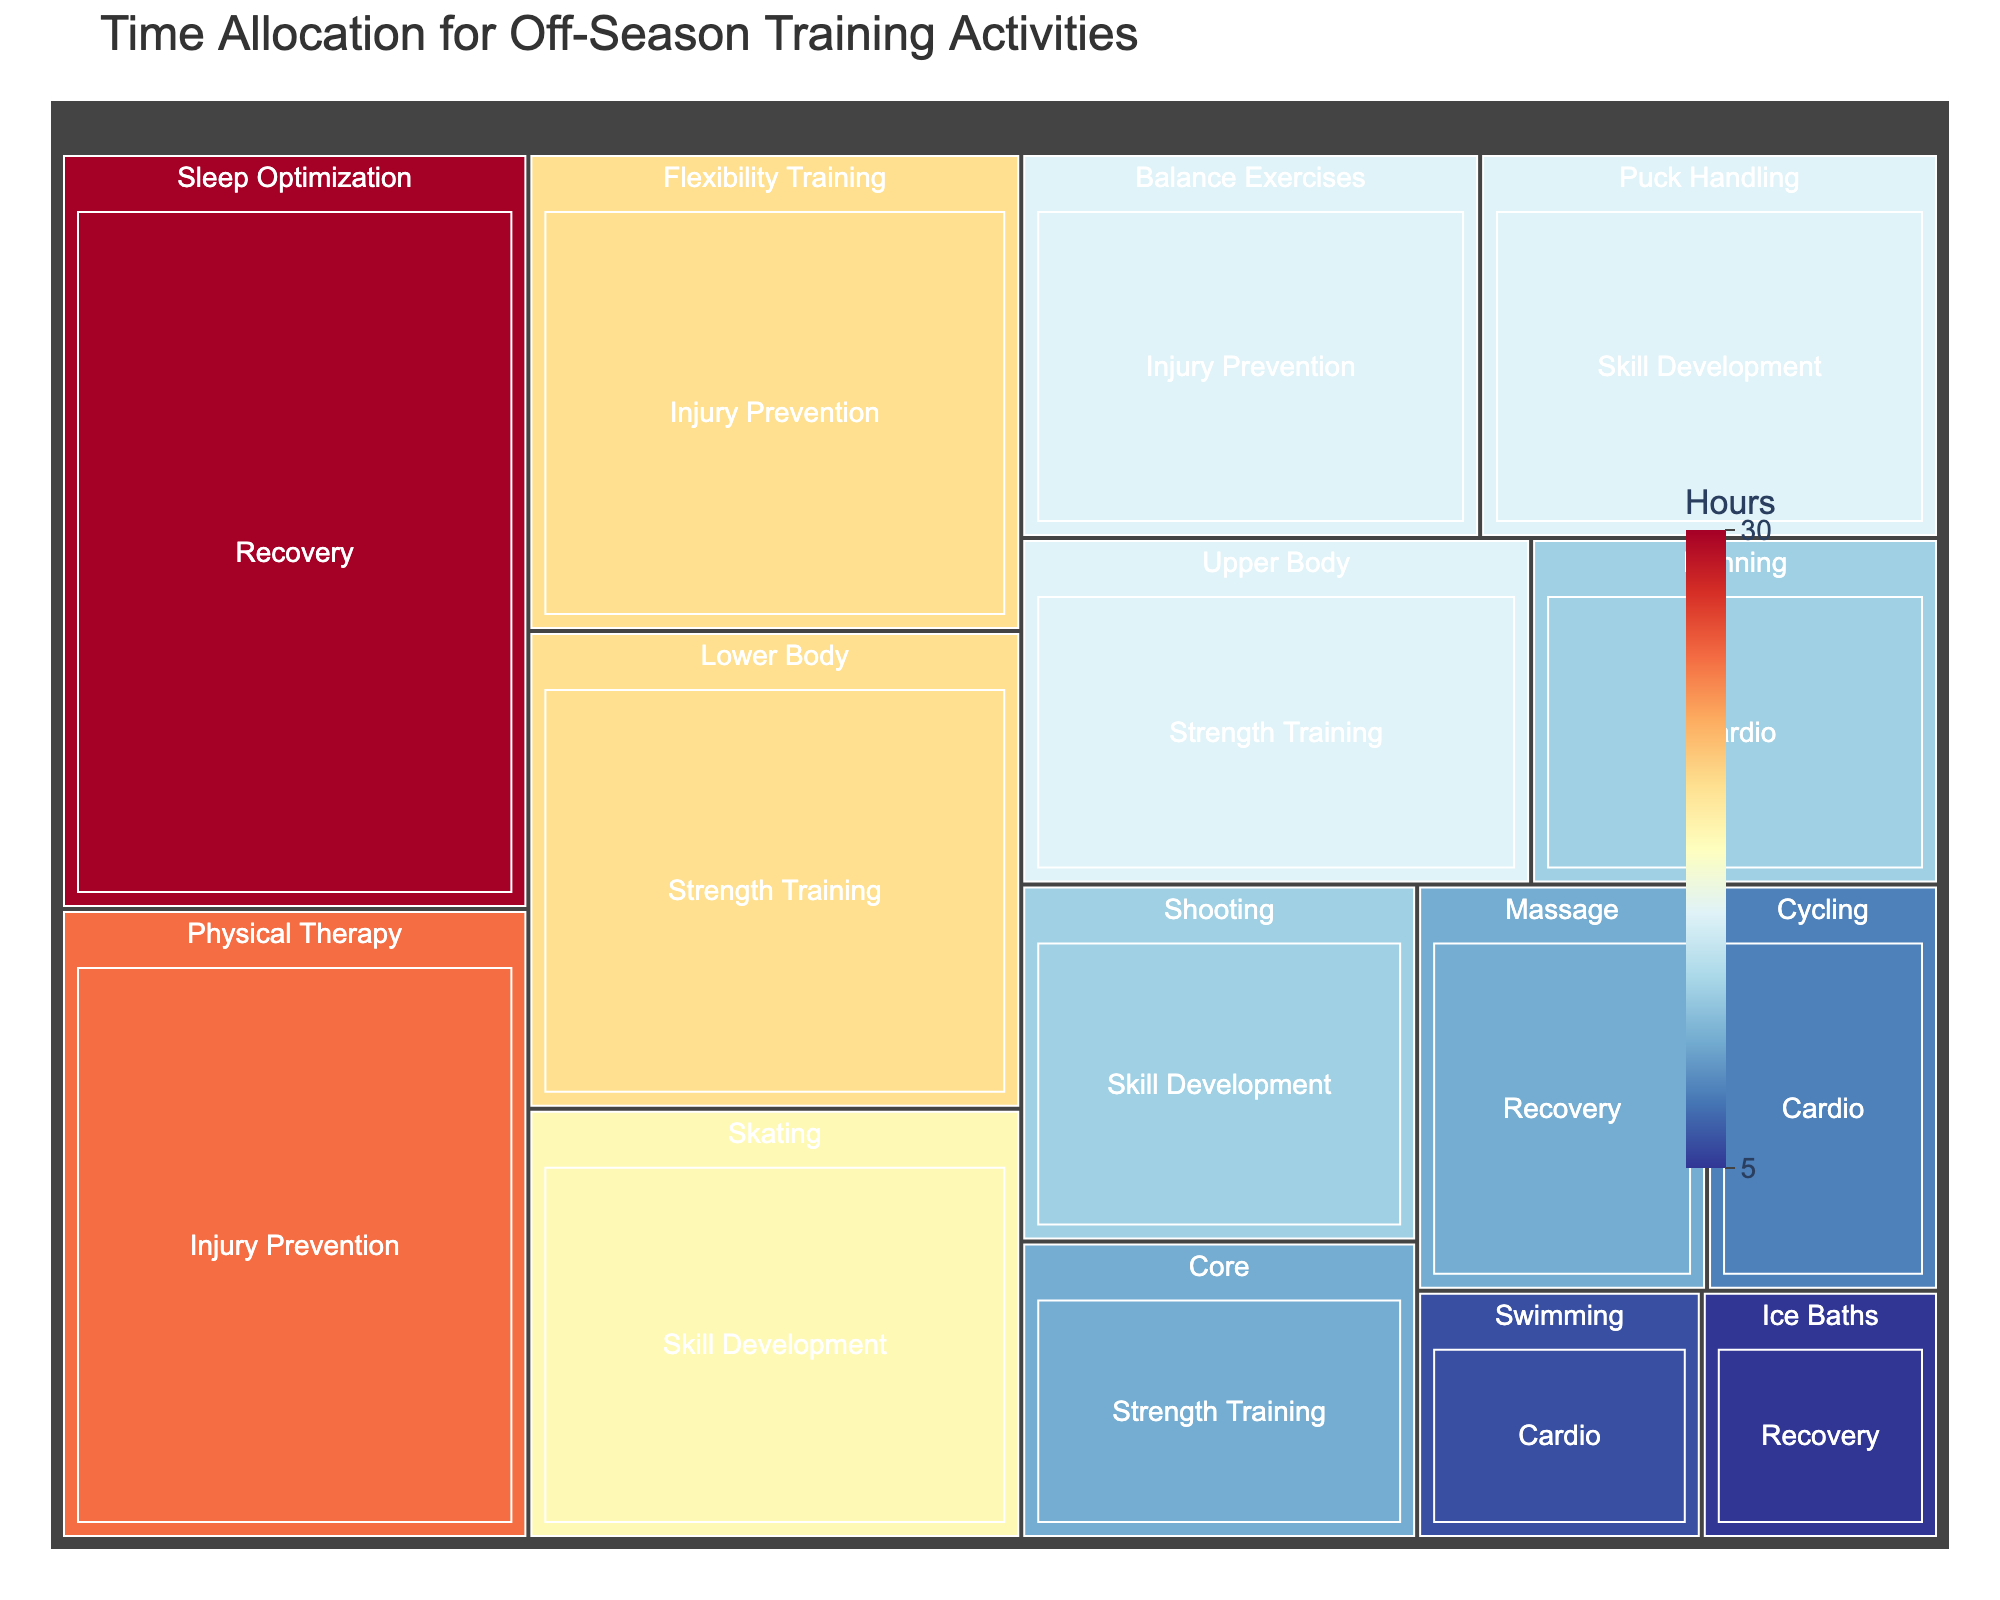What is the total number of hours spent on Injury Prevention activities? Sum the hours spent on Physical Therapy, Flexibility Training, and Balance Exercises. That is 25 + 20 + 15 = 60 hours.
Answer: 60 What category has the highest total hours of time allocation? By comparing the categories, you notice that Injury Prevention has 25 + 20 + 15 = 60 hours, which is the highest.
Answer: Injury Prevention Which activity in Skill Development takes the most time? By checking Skill Development, the activity with the highest hours is Skating with 18 hours.
Answer: Skating How many more hours are spent on Sleep Optimization compared to Massage in the Recovery category? In the Recovery category, Sleep Optimization is 30 hours, and Massage is 10 hours. The difference is 30 - 10 = 20 hours.
Answer: 20 What is the sum of hours spent on Cardio activities? Add up the hours for Running, Cycling, and Swimming. That is 12 + 8 + 6 = 26 hours.
Answer: 26 Which training activity has the least time allocated? Searching for the activity with the fewest hours, Ice Baths have 5 hours, which is the least.
Answer: Ice Baths Between Strength Training and Skill Development, which category has more total hours? Add the hours for Strength Training (20 + 15 + 10 = 45) and Skill Development (18 + 15 + 12 = 45). Since both sums up to 45 hours, both categories have the same total hours.
Answer: Both are equal What is the ratio of hours spent on Skating to total hours spent on Skill Development? The hours spent on Skating is 18. The total hours for Skill Development are 18 + 15 + 12 = 45. The ratio is 18/45 = 2/5 or 0.4.
Answer: 0.4 Which activity within Cardio has the least number of hours, and how many hours are allocated to it? Within Cardio, Swimming has the fewest hours at 6 hours
Answer: Swimming, 6 What is the percentage of total hours spent on Physical Therapy out of the total training hours? Physical Therapy has 25 hours. The total hours for all activities are the sum of all entries, i.e., 20 + 15 + 10 + 12 + 8 + 6 + 18 + 15 + 12 + 25 + 20 + 15 + 10 + 5 + 30 = 221 hours. The percentage is (25/221) * 100 ≈ 11.31%.
Answer: ~11.31% 